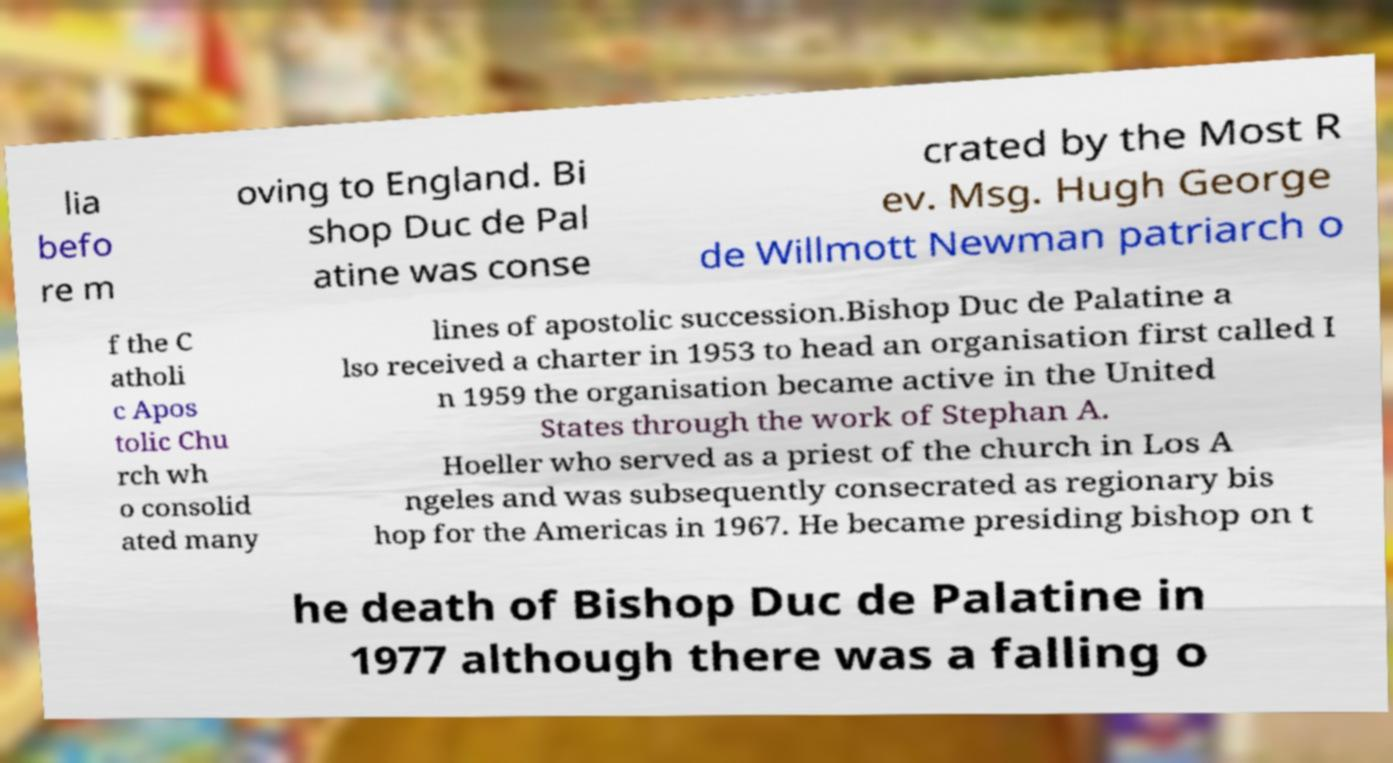For documentation purposes, I need the text within this image transcribed. Could you provide that? lia befo re m oving to England. Bi shop Duc de Pal atine was conse crated by the Most R ev. Msg. Hugh George de Willmott Newman patriarch o f the C atholi c Apos tolic Chu rch wh o consolid ated many lines of apostolic succession.Bishop Duc de Palatine a lso received a charter in 1953 to head an organisation first called I n 1959 the organisation became active in the United States through the work of Stephan A. Hoeller who served as a priest of the church in Los A ngeles and was subsequently consecrated as regionary bis hop for the Americas in 1967. He became presiding bishop on t he death of Bishop Duc de Palatine in 1977 although there was a falling o 